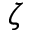<formula> <loc_0><loc_0><loc_500><loc_500>\zeta</formula> 